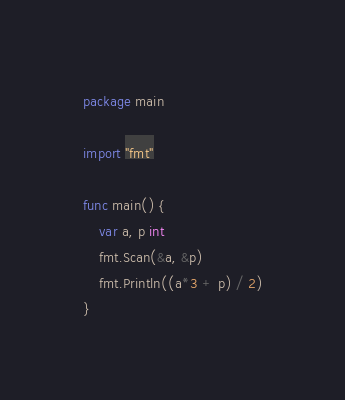<code> <loc_0><loc_0><loc_500><loc_500><_Go_>package main

import "fmt"

func main() {
	var a, p int
	fmt.Scan(&a, &p)
	fmt.Println((a*3 + p) / 2)
}
</code> 